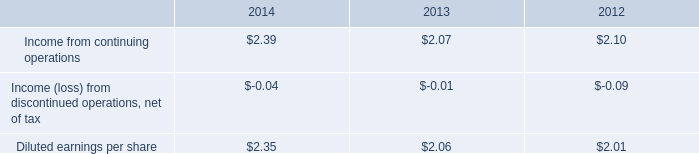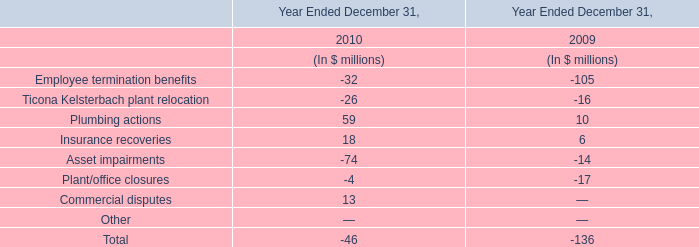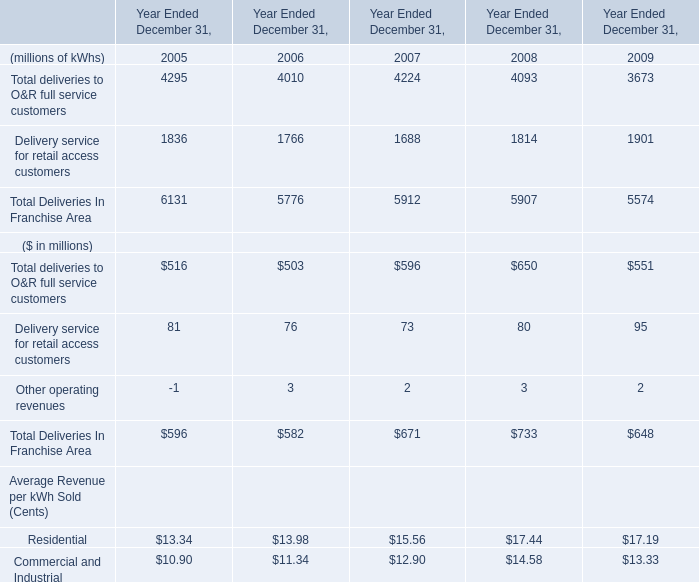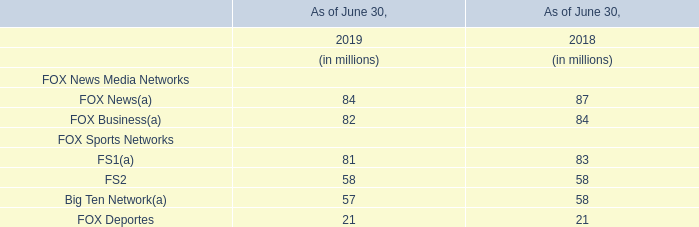by how much did income from continuing operations increase from 2012 to 2014? 
Computations: ((2.39 - 2.10) / 2.10)
Answer: 0.1381. 